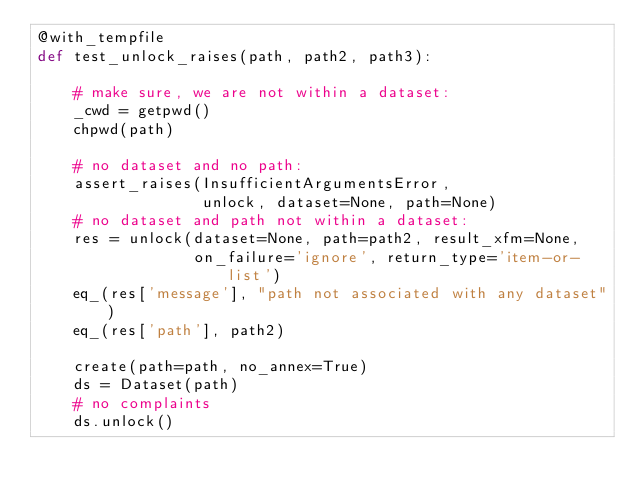<code> <loc_0><loc_0><loc_500><loc_500><_Python_>@with_tempfile
def test_unlock_raises(path, path2, path3):

    # make sure, we are not within a dataset:
    _cwd = getpwd()
    chpwd(path)

    # no dataset and no path:
    assert_raises(InsufficientArgumentsError,
                  unlock, dataset=None, path=None)
    # no dataset and path not within a dataset:
    res = unlock(dataset=None, path=path2, result_xfm=None,
                 on_failure='ignore', return_type='item-or-list')
    eq_(res['message'], "path not associated with any dataset")
    eq_(res['path'], path2)

    create(path=path, no_annex=True)
    ds = Dataset(path)
    # no complaints
    ds.unlock()
</code> 